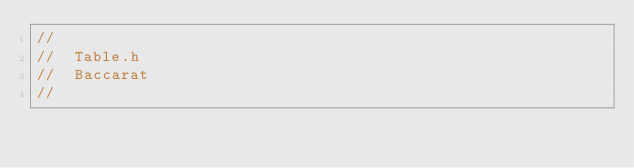<code> <loc_0><loc_0><loc_500><loc_500><_C_>//
//  Table.h
//  Baccarat
//</code> 